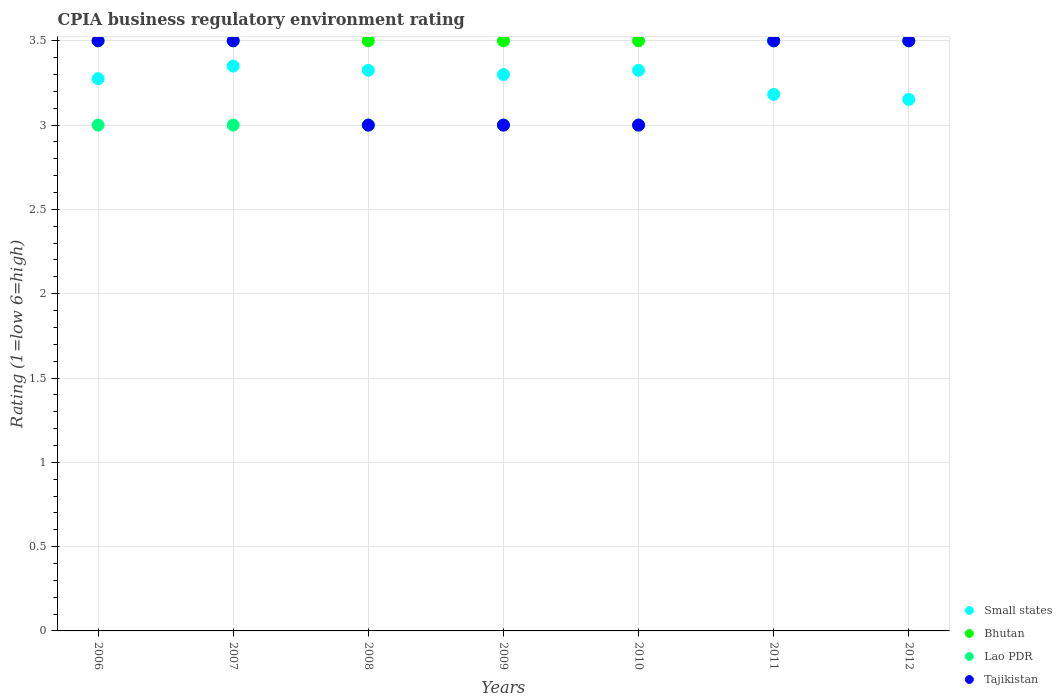Is the number of dotlines equal to the number of legend labels?
Provide a succinct answer. Yes. In which year was the CPIA rating in Small states maximum?
Your answer should be compact. 2007. What is the difference between the CPIA rating in Small states in 2011 and the CPIA rating in Tajikistan in 2007?
Keep it short and to the point. -0.32. What is the average CPIA rating in Tajikistan per year?
Your answer should be very brief. 3.29. In how many years, is the CPIA rating in Small states greater than 3?
Provide a succinct answer. 7. What is the difference between the highest and the lowest CPIA rating in Tajikistan?
Your response must be concise. 0.5. Is it the case that in every year, the sum of the CPIA rating in Small states and CPIA rating in Tajikistan  is greater than the sum of CPIA rating in Lao PDR and CPIA rating in Bhutan?
Offer a very short reply. No. Is it the case that in every year, the sum of the CPIA rating in Lao PDR and CPIA rating in Bhutan  is greater than the CPIA rating in Tajikistan?
Keep it short and to the point. Yes. Is the CPIA rating in Tajikistan strictly greater than the CPIA rating in Lao PDR over the years?
Offer a very short reply. No. Is the CPIA rating in Bhutan strictly less than the CPIA rating in Lao PDR over the years?
Give a very brief answer. No. How many years are there in the graph?
Make the answer very short. 7. Are the values on the major ticks of Y-axis written in scientific E-notation?
Your answer should be compact. No. Does the graph contain any zero values?
Your answer should be very brief. No. How many legend labels are there?
Your answer should be very brief. 4. What is the title of the graph?
Provide a succinct answer. CPIA business regulatory environment rating. Does "St. Lucia" appear as one of the legend labels in the graph?
Offer a terse response. No. What is the label or title of the Y-axis?
Offer a very short reply. Rating (1=low 6=high). What is the Rating (1=low 6=high) in Small states in 2006?
Keep it short and to the point. 3.27. What is the Rating (1=low 6=high) of Bhutan in 2006?
Your answer should be very brief. 3.5. What is the Rating (1=low 6=high) of Lao PDR in 2006?
Offer a terse response. 3. What is the Rating (1=low 6=high) of Small states in 2007?
Provide a succinct answer. 3.35. What is the Rating (1=low 6=high) in Lao PDR in 2007?
Your answer should be compact. 3. What is the Rating (1=low 6=high) in Tajikistan in 2007?
Make the answer very short. 3.5. What is the Rating (1=low 6=high) of Small states in 2008?
Offer a very short reply. 3.33. What is the Rating (1=low 6=high) in Bhutan in 2008?
Provide a short and direct response. 3.5. What is the Rating (1=low 6=high) in Lao PDR in 2008?
Ensure brevity in your answer.  3. What is the Rating (1=low 6=high) of Small states in 2009?
Keep it short and to the point. 3.3. What is the Rating (1=low 6=high) of Lao PDR in 2009?
Give a very brief answer. 3. What is the Rating (1=low 6=high) in Tajikistan in 2009?
Your answer should be very brief. 3. What is the Rating (1=low 6=high) in Small states in 2010?
Provide a succinct answer. 3.33. What is the Rating (1=low 6=high) of Small states in 2011?
Your response must be concise. 3.18. What is the Rating (1=low 6=high) in Tajikistan in 2011?
Provide a succinct answer. 3.5. What is the Rating (1=low 6=high) in Small states in 2012?
Make the answer very short. 3.15. What is the Rating (1=low 6=high) of Tajikistan in 2012?
Ensure brevity in your answer.  3.5. Across all years, what is the maximum Rating (1=low 6=high) of Small states?
Keep it short and to the point. 3.35. Across all years, what is the maximum Rating (1=low 6=high) of Bhutan?
Provide a short and direct response. 3.5. Across all years, what is the maximum Rating (1=low 6=high) of Lao PDR?
Provide a succinct answer. 3.5. Across all years, what is the maximum Rating (1=low 6=high) in Tajikistan?
Keep it short and to the point. 3.5. Across all years, what is the minimum Rating (1=low 6=high) in Small states?
Offer a very short reply. 3.15. Across all years, what is the minimum Rating (1=low 6=high) in Lao PDR?
Keep it short and to the point. 3. Across all years, what is the minimum Rating (1=low 6=high) in Tajikistan?
Your answer should be compact. 3. What is the total Rating (1=low 6=high) in Small states in the graph?
Provide a short and direct response. 22.91. What is the total Rating (1=low 6=high) of Bhutan in the graph?
Ensure brevity in your answer.  24.5. What is the difference between the Rating (1=low 6=high) of Small states in 2006 and that in 2007?
Provide a short and direct response. -0.07. What is the difference between the Rating (1=low 6=high) in Bhutan in 2006 and that in 2007?
Offer a very short reply. 0. What is the difference between the Rating (1=low 6=high) of Tajikistan in 2006 and that in 2007?
Ensure brevity in your answer.  0. What is the difference between the Rating (1=low 6=high) in Small states in 2006 and that in 2008?
Your answer should be very brief. -0.05. What is the difference between the Rating (1=low 6=high) of Bhutan in 2006 and that in 2008?
Give a very brief answer. 0. What is the difference between the Rating (1=low 6=high) in Lao PDR in 2006 and that in 2008?
Your response must be concise. 0. What is the difference between the Rating (1=low 6=high) in Small states in 2006 and that in 2009?
Your answer should be very brief. -0.03. What is the difference between the Rating (1=low 6=high) of Lao PDR in 2006 and that in 2009?
Provide a succinct answer. 0. What is the difference between the Rating (1=low 6=high) of Tajikistan in 2006 and that in 2009?
Keep it short and to the point. 0.5. What is the difference between the Rating (1=low 6=high) of Small states in 2006 and that in 2010?
Ensure brevity in your answer.  -0.05. What is the difference between the Rating (1=low 6=high) in Lao PDR in 2006 and that in 2010?
Keep it short and to the point. 0. What is the difference between the Rating (1=low 6=high) of Small states in 2006 and that in 2011?
Give a very brief answer. 0.09. What is the difference between the Rating (1=low 6=high) in Lao PDR in 2006 and that in 2011?
Provide a short and direct response. -0.5. What is the difference between the Rating (1=low 6=high) in Tajikistan in 2006 and that in 2011?
Offer a very short reply. 0. What is the difference between the Rating (1=low 6=high) of Small states in 2006 and that in 2012?
Provide a short and direct response. 0.12. What is the difference between the Rating (1=low 6=high) in Bhutan in 2006 and that in 2012?
Provide a succinct answer. 0. What is the difference between the Rating (1=low 6=high) of Tajikistan in 2006 and that in 2012?
Provide a succinct answer. 0. What is the difference between the Rating (1=low 6=high) of Small states in 2007 and that in 2008?
Your answer should be very brief. 0.03. What is the difference between the Rating (1=low 6=high) of Bhutan in 2007 and that in 2008?
Give a very brief answer. 0. What is the difference between the Rating (1=low 6=high) in Lao PDR in 2007 and that in 2008?
Your answer should be compact. 0. What is the difference between the Rating (1=low 6=high) in Tajikistan in 2007 and that in 2008?
Ensure brevity in your answer.  0.5. What is the difference between the Rating (1=low 6=high) of Small states in 2007 and that in 2009?
Your answer should be very brief. 0.05. What is the difference between the Rating (1=low 6=high) of Tajikistan in 2007 and that in 2009?
Make the answer very short. 0.5. What is the difference between the Rating (1=low 6=high) in Small states in 2007 and that in 2010?
Your answer should be compact. 0.03. What is the difference between the Rating (1=low 6=high) in Bhutan in 2007 and that in 2010?
Offer a terse response. 0. What is the difference between the Rating (1=low 6=high) of Small states in 2007 and that in 2011?
Offer a very short reply. 0.17. What is the difference between the Rating (1=low 6=high) in Lao PDR in 2007 and that in 2011?
Your answer should be very brief. -0.5. What is the difference between the Rating (1=low 6=high) in Small states in 2007 and that in 2012?
Ensure brevity in your answer.  0.2. What is the difference between the Rating (1=low 6=high) in Lao PDR in 2007 and that in 2012?
Keep it short and to the point. -0.5. What is the difference between the Rating (1=low 6=high) in Tajikistan in 2007 and that in 2012?
Your response must be concise. 0. What is the difference between the Rating (1=low 6=high) of Small states in 2008 and that in 2009?
Your response must be concise. 0.03. What is the difference between the Rating (1=low 6=high) in Lao PDR in 2008 and that in 2009?
Ensure brevity in your answer.  0. What is the difference between the Rating (1=low 6=high) in Tajikistan in 2008 and that in 2009?
Provide a short and direct response. 0. What is the difference between the Rating (1=low 6=high) in Bhutan in 2008 and that in 2010?
Your answer should be compact. 0. What is the difference between the Rating (1=low 6=high) in Tajikistan in 2008 and that in 2010?
Provide a short and direct response. 0. What is the difference between the Rating (1=low 6=high) in Small states in 2008 and that in 2011?
Your answer should be compact. 0.14. What is the difference between the Rating (1=low 6=high) of Tajikistan in 2008 and that in 2011?
Keep it short and to the point. -0.5. What is the difference between the Rating (1=low 6=high) of Small states in 2008 and that in 2012?
Give a very brief answer. 0.17. What is the difference between the Rating (1=low 6=high) in Bhutan in 2008 and that in 2012?
Provide a succinct answer. 0. What is the difference between the Rating (1=low 6=high) of Lao PDR in 2008 and that in 2012?
Make the answer very short. -0.5. What is the difference between the Rating (1=low 6=high) in Small states in 2009 and that in 2010?
Ensure brevity in your answer.  -0.03. What is the difference between the Rating (1=low 6=high) in Lao PDR in 2009 and that in 2010?
Give a very brief answer. 0. What is the difference between the Rating (1=low 6=high) in Tajikistan in 2009 and that in 2010?
Your answer should be compact. 0. What is the difference between the Rating (1=low 6=high) of Small states in 2009 and that in 2011?
Provide a short and direct response. 0.12. What is the difference between the Rating (1=low 6=high) in Small states in 2009 and that in 2012?
Your response must be concise. 0.15. What is the difference between the Rating (1=low 6=high) of Lao PDR in 2009 and that in 2012?
Your answer should be compact. -0.5. What is the difference between the Rating (1=low 6=high) in Tajikistan in 2009 and that in 2012?
Your answer should be compact. -0.5. What is the difference between the Rating (1=low 6=high) of Small states in 2010 and that in 2011?
Your answer should be compact. 0.14. What is the difference between the Rating (1=low 6=high) of Bhutan in 2010 and that in 2011?
Offer a terse response. 0. What is the difference between the Rating (1=low 6=high) in Tajikistan in 2010 and that in 2011?
Ensure brevity in your answer.  -0.5. What is the difference between the Rating (1=low 6=high) of Small states in 2010 and that in 2012?
Provide a succinct answer. 0.17. What is the difference between the Rating (1=low 6=high) in Bhutan in 2010 and that in 2012?
Provide a succinct answer. 0. What is the difference between the Rating (1=low 6=high) in Small states in 2011 and that in 2012?
Make the answer very short. 0.03. What is the difference between the Rating (1=low 6=high) of Bhutan in 2011 and that in 2012?
Provide a short and direct response. 0. What is the difference between the Rating (1=low 6=high) of Tajikistan in 2011 and that in 2012?
Your answer should be very brief. 0. What is the difference between the Rating (1=low 6=high) in Small states in 2006 and the Rating (1=low 6=high) in Bhutan in 2007?
Give a very brief answer. -0.23. What is the difference between the Rating (1=low 6=high) of Small states in 2006 and the Rating (1=low 6=high) of Lao PDR in 2007?
Keep it short and to the point. 0.28. What is the difference between the Rating (1=low 6=high) of Small states in 2006 and the Rating (1=low 6=high) of Tajikistan in 2007?
Give a very brief answer. -0.23. What is the difference between the Rating (1=low 6=high) in Bhutan in 2006 and the Rating (1=low 6=high) in Tajikistan in 2007?
Your answer should be very brief. 0. What is the difference between the Rating (1=low 6=high) in Lao PDR in 2006 and the Rating (1=low 6=high) in Tajikistan in 2007?
Provide a short and direct response. -0.5. What is the difference between the Rating (1=low 6=high) in Small states in 2006 and the Rating (1=low 6=high) in Bhutan in 2008?
Provide a short and direct response. -0.23. What is the difference between the Rating (1=low 6=high) of Small states in 2006 and the Rating (1=low 6=high) of Lao PDR in 2008?
Give a very brief answer. 0.28. What is the difference between the Rating (1=low 6=high) of Small states in 2006 and the Rating (1=low 6=high) of Tajikistan in 2008?
Keep it short and to the point. 0.28. What is the difference between the Rating (1=low 6=high) in Bhutan in 2006 and the Rating (1=low 6=high) in Lao PDR in 2008?
Provide a succinct answer. 0.5. What is the difference between the Rating (1=low 6=high) in Bhutan in 2006 and the Rating (1=low 6=high) in Tajikistan in 2008?
Provide a succinct answer. 0.5. What is the difference between the Rating (1=low 6=high) in Small states in 2006 and the Rating (1=low 6=high) in Bhutan in 2009?
Your answer should be compact. -0.23. What is the difference between the Rating (1=low 6=high) of Small states in 2006 and the Rating (1=low 6=high) of Lao PDR in 2009?
Offer a terse response. 0.28. What is the difference between the Rating (1=low 6=high) of Small states in 2006 and the Rating (1=low 6=high) of Tajikistan in 2009?
Provide a succinct answer. 0.28. What is the difference between the Rating (1=low 6=high) in Bhutan in 2006 and the Rating (1=low 6=high) in Lao PDR in 2009?
Provide a short and direct response. 0.5. What is the difference between the Rating (1=low 6=high) in Lao PDR in 2006 and the Rating (1=low 6=high) in Tajikistan in 2009?
Offer a very short reply. 0. What is the difference between the Rating (1=low 6=high) of Small states in 2006 and the Rating (1=low 6=high) of Bhutan in 2010?
Give a very brief answer. -0.23. What is the difference between the Rating (1=low 6=high) of Small states in 2006 and the Rating (1=low 6=high) of Lao PDR in 2010?
Provide a succinct answer. 0.28. What is the difference between the Rating (1=low 6=high) of Small states in 2006 and the Rating (1=low 6=high) of Tajikistan in 2010?
Your response must be concise. 0.28. What is the difference between the Rating (1=low 6=high) of Bhutan in 2006 and the Rating (1=low 6=high) of Tajikistan in 2010?
Provide a short and direct response. 0.5. What is the difference between the Rating (1=low 6=high) of Small states in 2006 and the Rating (1=low 6=high) of Bhutan in 2011?
Give a very brief answer. -0.23. What is the difference between the Rating (1=low 6=high) of Small states in 2006 and the Rating (1=low 6=high) of Lao PDR in 2011?
Provide a succinct answer. -0.23. What is the difference between the Rating (1=low 6=high) in Small states in 2006 and the Rating (1=low 6=high) in Tajikistan in 2011?
Make the answer very short. -0.23. What is the difference between the Rating (1=low 6=high) of Bhutan in 2006 and the Rating (1=low 6=high) of Lao PDR in 2011?
Provide a short and direct response. 0. What is the difference between the Rating (1=low 6=high) of Bhutan in 2006 and the Rating (1=low 6=high) of Tajikistan in 2011?
Offer a very short reply. 0. What is the difference between the Rating (1=low 6=high) in Small states in 2006 and the Rating (1=low 6=high) in Bhutan in 2012?
Ensure brevity in your answer.  -0.23. What is the difference between the Rating (1=low 6=high) in Small states in 2006 and the Rating (1=low 6=high) in Lao PDR in 2012?
Provide a short and direct response. -0.23. What is the difference between the Rating (1=low 6=high) of Small states in 2006 and the Rating (1=low 6=high) of Tajikistan in 2012?
Offer a very short reply. -0.23. What is the difference between the Rating (1=low 6=high) in Bhutan in 2006 and the Rating (1=low 6=high) in Lao PDR in 2012?
Ensure brevity in your answer.  0. What is the difference between the Rating (1=low 6=high) of Lao PDR in 2007 and the Rating (1=low 6=high) of Tajikistan in 2008?
Make the answer very short. 0. What is the difference between the Rating (1=low 6=high) in Small states in 2007 and the Rating (1=low 6=high) in Bhutan in 2009?
Offer a terse response. -0.15. What is the difference between the Rating (1=low 6=high) in Small states in 2007 and the Rating (1=low 6=high) in Tajikistan in 2010?
Your response must be concise. 0.35. What is the difference between the Rating (1=low 6=high) in Bhutan in 2007 and the Rating (1=low 6=high) in Tajikistan in 2010?
Your answer should be very brief. 0.5. What is the difference between the Rating (1=low 6=high) in Lao PDR in 2007 and the Rating (1=low 6=high) in Tajikistan in 2010?
Keep it short and to the point. 0. What is the difference between the Rating (1=low 6=high) in Bhutan in 2007 and the Rating (1=low 6=high) in Lao PDR in 2011?
Ensure brevity in your answer.  0. What is the difference between the Rating (1=low 6=high) of Bhutan in 2007 and the Rating (1=low 6=high) of Tajikistan in 2011?
Provide a succinct answer. 0. What is the difference between the Rating (1=low 6=high) in Lao PDR in 2007 and the Rating (1=low 6=high) in Tajikistan in 2011?
Keep it short and to the point. -0.5. What is the difference between the Rating (1=low 6=high) in Small states in 2007 and the Rating (1=low 6=high) in Tajikistan in 2012?
Give a very brief answer. -0.15. What is the difference between the Rating (1=low 6=high) of Bhutan in 2007 and the Rating (1=low 6=high) of Lao PDR in 2012?
Your answer should be very brief. 0. What is the difference between the Rating (1=low 6=high) of Bhutan in 2007 and the Rating (1=low 6=high) of Tajikistan in 2012?
Your response must be concise. 0. What is the difference between the Rating (1=low 6=high) in Lao PDR in 2007 and the Rating (1=low 6=high) in Tajikistan in 2012?
Make the answer very short. -0.5. What is the difference between the Rating (1=low 6=high) of Small states in 2008 and the Rating (1=low 6=high) of Bhutan in 2009?
Offer a terse response. -0.17. What is the difference between the Rating (1=low 6=high) of Small states in 2008 and the Rating (1=low 6=high) of Lao PDR in 2009?
Ensure brevity in your answer.  0.33. What is the difference between the Rating (1=low 6=high) of Small states in 2008 and the Rating (1=low 6=high) of Tajikistan in 2009?
Offer a terse response. 0.33. What is the difference between the Rating (1=low 6=high) in Small states in 2008 and the Rating (1=low 6=high) in Bhutan in 2010?
Your response must be concise. -0.17. What is the difference between the Rating (1=low 6=high) of Small states in 2008 and the Rating (1=low 6=high) of Lao PDR in 2010?
Keep it short and to the point. 0.33. What is the difference between the Rating (1=low 6=high) of Small states in 2008 and the Rating (1=low 6=high) of Tajikistan in 2010?
Your answer should be very brief. 0.33. What is the difference between the Rating (1=low 6=high) in Bhutan in 2008 and the Rating (1=low 6=high) in Tajikistan in 2010?
Provide a succinct answer. 0.5. What is the difference between the Rating (1=low 6=high) in Small states in 2008 and the Rating (1=low 6=high) in Bhutan in 2011?
Provide a succinct answer. -0.17. What is the difference between the Rating (1=low 6=high) in Small states in 2008 and the Rating (1=low 6=high) in Lao PDR in 2011?
Offer a terse response. -0.17. What is the difference between the Rating (1=low 6=high) in Small states in 2008 and the Rating (1=low 6=high) in Tajikistan in 2011?
Offer a terse response. -0.17. What is the difference between the Rating (1=low 6=high) of Bhutan in 2008 and the Rating (1=low 6=high) of Lao PDR in 2011?
Ensure brevity in your answer.  0. What is the difference between the Rating (1=low 6=high) of Bhutan in 2008 and the Rating (1=low 6=high) of Tajikistan in 2011?
Keep it short and to the point. 0. What is the difference between the Rating (1=low 6=high) in Small states in 2008 and the Rating (1=low 6=high) in Bhutan in 2012?
Keep it short and to the point. -0.17. What is the difference between the Rating (1=low 6=high) in Small states in 2008 and the Rating (1=low 6=high) in Lao PDR in 2012?
Offer a terse response. -0.17. What is the difference between the Rating (1=low 6=high) in Small states in 2008 and the Rating (1=low 6=high) in Tajikistan in 2012?
Make the answer very short. -0.17. What is the difference between the Rating (1=low 6=high) in Bhutan in 2008 and the Rating (1=low 6=high) in Lao PDR in 2012?
Your answer should be very brief. 0. What is the difference between the Rating (1=low 6=high) in Bhutan in 2008 and the Rating (1=low 6=high) in Tajikistan in 2012?
Ensure brevity in your answer.  0. What is the difference between the Rating (1=low 6=high) of Lao PDR in 2008 and the Rating (1=low 6=high) of Tajikistan in 2012?
Provide a succinct answer. -0.5. What is the difference between the Rating (1=low 6=high) in Small states in 2009 and the Rating (1=low 6=high) in Bhutan in 2010?
Keep it short and to the point. -0.2. What is the difference between the Rating (1=low 6=high) in Small states in 2009 and the Rating (1=low 6=high) in Tajikistan in 2010?
Make the answer very short. 0.3. What is the difference between the Rating (1=low 6=high) in Lao PDR in 2009 and the Rating (1=low 6=high) in Tajikistan in 2011?
Your answer should be compact. -0.5. What is the difference between the Rating (1=low 6=high) in Small states in 2009 and the Rating (1=low 6=high) in Bhutan in 2012?
Offer a very short reply. -0.2. What is the difference between the Rating (1=low 6=high) of Bhutan in 2009 and the Rating (1=low 6=high) of Lao PDR in 2012?
Your answer should be compact. 0. What is the difference between the Rating (1=low 6=high) of Small states in 2010 and the Rating (1=low 6=high) of Bhutan in 2011?
Your answer should be very brief. -0.17. What is the difference between the Rating (1=low 6=high) of Small states in 2010 and the Rating (1=low 6=high) of Lao PDR in 2011?
Ensure brevity in your answer.  -0.17. What is the difference between the Rating (1=low 6=high) in Small states in 2010 and the Rating (1=low 6=high) in Tajikistan in 2011?
Your response must be concise. -0.17. What is the difference between the Rating (1=low 6=high) of Bhutan in 2010 and the Rating (1=low 6=high) of Lao PDR in 2011?
Your answer should be very brief. 0. What is the difference between the Rating (1=low 6=high) of Bhutan in 2010 and the Rating (1=low 6=high) of Tajikistan in 2011?
Your answer should be compact. 0. What is the difference between the Rating (1=low 6=high) of Lao PDR in 2010 and the Rating (1=low 6=high) of Tajikistan in 2011?
Offer a very short reply. -0.5. What is the difference between the Rating (1=low 6=high) in Small states in 2010 and the Rating (1=low 6=high) in Bhutan in 2012?
Your answer should be very brief. -0.17. What is the difference between the Rating (1=low 6=high) of Small states in 2010 and the Rating (1=low 6=high) of Lao PDR in 2012?
Offer a very short reply. -0.17. What is the difference between the Rating (1=low 6=high) of Small states in 2010 and the Rating (1=low 6=high) of Tajikistan in 2012?
Keep it short and to the point. -0.17. What is the difference between the Rating (1=low 6=high) of Bhutan in 2010 and the Rating (1=low 6=high) of Tajikistan in 2012?
Keep it short and to the point. 0. What is the difference between the Rating (1=low 6=high) of Small states in 2011 and the Rating (1=low 6=high) of Bhutan in 2012?
Keep it short and to the point. -0.32. What is the difference between the Rating (1=low 6=high) of Small states in 2011 and the Rating (1=low 6=high) of Lao PDR in 2012?
Make the answer very short. -0.32. What is the difference between the Rating (1=low 6=high) of Small states in 2011 and the Rating (1=low 6=high) of Tajikistan in 2012?
Your response must be concise. -0.32. What is the difference between the Rating (1=low 6=high) of Lao PDR in 2011 and the Rating (1=low 6=high) of Tajikistan in 2012?
Provide a short and direct response. 0. What is the average Rating (1=low 6=high) of Small states per year?
Give a very brief answer. 3.27. What is the average Rating (1=low 6=high) in Lao PDR per year?
Make the answer very short. 3.14. What is the average Rating (1=low 6=high) in Tajikistan per year?
Provide a short and direct response. 3.29. In the year 2006, what is the difference between the Rating (1=low 6=high) in Small states and Rating (1=low 6=high) in Bhutan?
Provide a succinct answer. -0.23. In the year 2006, what is the difference between the Rating (1=low 6=high) of Small states and Rating (1=low 6=high) of Lao PDR?
Ensure brevity in your answer.  0.28. In the year 2006, what is the difference between the Rating (1=low 6=high) of Small states and Rating (1=low 6=high) of Tajikistan?
Ensure brevity in your answer.  -0.23. In the year 2006, what is the difference between the Rating (1=low 6=high) of Bhutan and Rating (1=low 6=high) of Lao PDR?
Ensure brevity in your answer.  0.5. In the year 2006, what is the difference between the Rating (1=low 6=high) in Bhutan and Rating (1=low 6=high) in Tajikistan?
Give a very brief answer. 0. In the year 2007, what is the difference between the Rating (1=low 6=high) in Small states and Rating (1=low 6=high) in Lao PDR?
Make the answer very short. 0.35. In the year 2007, what is the difference between the Rating (1=low 6=high) of Small states and Rating (1=low 6=high) of Tajikistan?
Ensure brevity in your answer.  -0.15. In the year 2007, what is the difference between the Rating (1=low 6=high) of Bhutan and Rating (1=low 6=high) of Lao PDR?
Keep it short and to the point. 0.5. In the year 2007, what is the difference between the Rating (1=low 6=high) of Bhutan and Rating (1=low 6=high) of Tajikistan?
Make the answer very short. 0. In the year 2007, what is the difference between the Rating (1=low 6=high) in Lao PDR and Rating (1=low 6=high) in Tajikistan?
Your response must be concise. -0.5. In the year 2008, what is the difference between the Rating (1=low 6=high) of Small states and Rating (1=low 6=high) of Bhutan?
Ensure brevity in your answer.  -0.17. In the year 2008, what is the difference between the Rating (1=low 6=high) in Small states and Rating (1=low 6=high) in Lao PDR?
Provide a succinct answer. 0.33. In the year 2008, what is the difference between the Rating (1=low 6=high) in Small states and Rating (1=low 6=high) in Tajikistan?
Your response must be concise. 0.33. In the year 2008, what is the difference between the Rating (1=low 6=high) of Bhutan and Rating (1=low 6=high) of Tajikistan?
Make the answer very short. 0.5. In the year 2009, what is the difference between the Rating (1=low 6=high) in Small states and Rating (1=low 6=high) in Tajikistan?
Your answer should be compact. 0.3. In the year 2009, what is the difference between the Rating (1=low 6=high) in Bhutan and Rating (1=low 6=high) in Lao PDR?
Provide a succinct answer. 0.5. In the year 2009, what is the difference between the Rating (1=low 6=high) of Bhutan and Rating (1=low 6=high) of Tajikistan?
Make the answer very short. 0.5. In the year 2009, what is the difference between the Rating (1=low 6=high) of Lao PDR and Rating (1=low 6=high) of Tajikistan?
Provide a succinct answer. 0. In the year 2010, what is the difference between the Rating (1=low 6=high) of Small states and Rating (1=low 6=high) of Bhutan?
Offer a very short reply. -0.17. In the year 2010, what is the difference between the Rating (1=low 6=high) of Small states and Rating (1=low 6=high) of Lao PDR?
Provide a short and direct response. 0.33. In the year 2010, what is the difference between the Rating (1=low 6=high) of Small states and Rating (1=low 6=high) of Tajikistan?
Give a very brief answer. 0.33. In the year 2010, what is the difference between the Rating (1=low 6=high) of Bhutan and Rating (1=low 6=high) of Lao PDR?
Give a very brief answer. 0.5. In the year 2010, what is the difference between the Rating (1=low 6=high) of Lao PDR and Rating (1=low 6=high) of Tajikistan?
Offer a very short reply. 0. In the year 2011, what is the difference between the Rating (1=low 6=high) in Small states and Rating (1=low 6=high) in Bhutan?
Keep it short and to the point. -0.32. In the year 2011, what is the difference between the Rating (1=low 6=high) of Small states and Rating (1=low 6=high) of Lao PDR?
Your response must be concise. -0.32. In the year 2011, what is the difference between the Rating (1=low 6=high) of Small states and Rating (1=low 6=high) of Tajikistan?
Your answer should be very brief. -0.32. In the year 2011, what is the difference between the Rating (1=low 6=high) in Bhutan and Rating (1=low 6=high) in Lao PDR?
Give a very brief answer. 0. In the year 2012, what is the difference between the Rating (1=low 6=high) of Small states and Rating (1=low 6=high) of Bhutan?
Provide a short and direct response. -0.35. In the year 2012, what is the difference between the Rating (1=low 6=high) of Small states and Rating (1=low 6=high) of Lao PDR?
Your answer should be compact. -0.35. In the year 2012, what is the difference between the Rating (1=low 6=high) in Small states and Rating (1=low 6=high) in Tajikistan?
Make the answer very short. -0.35. In the year 2012, what is the difference between the Rating (1=low 6=high) of Bhutan and Rating (1=low 6=high) of Tajikistan?
Ensure brevity in your answer.  0. What is the ratio of the Rating (1=low 6=high) of Small states in 2006 to that in 2007?
Offer a terse response. 0.98. What is the ratio of the Rating (1=low 6=high) of Lao PDR in 2006 to that in 2007?
Provide a short and direct response. 1. What is the ratio of the Rating (1=low 6=high) in Small states in 2006 to that in 2009?
Provide a short and direct response. 0.99. What is the ratio of the Rating (1=low 6=high) in Bhutan in 2006 to that in 2009?
Offer a very short reply. 1. What is the ratio of the Rating (1=low 6=high) in Lao PDR in 2006 to that in 2009?
Ensure brevity in your answer.  1. What is the ratio of the Rating (1=low 6=high) of Bhutan in 2006 to that in 2010?
Your response must be concise. 1. What is the ratio of the Rating (1=low 6=high) of Lao PDR in 2006 to that in 2010?
Give a very brief answer. 1. What is the ratio of the Rating (1=low 6=high) in Small states in 2006 to that in 2011?
Provide a short and direct response. 1.03. What is the ratio of the Rating (1=low 6=high) in Bhutan in 2006 to that in 2011?
Make the answer very short. 1. What is the ratio of the Rating (1=low 6=high) in Small states in 2006 to that in 2012?
Give a very brief answer. 1.04. What is the ratio of the Rating (1=low 6=high) of Bhutan in 2006 to that in 2012?
Your answer should be very brief. 1. What is the ratio of the Rating (1=low 6=high) in Tajikistan in 2006 to that in 2012?
Your response must be concise. 1. What is the ratio of the Rating (1=low 6=high) in Small states in 2007 to that in 2008?
Offer a very short reply. 1.01. What is the ratio of the Rating (1=low 6=high) of Lao PDR in 2007 to that in 2008?
Offer a very short reply. 1. What is the ratio of the Rating (1=low 6=high) in Tajikistan in 2007 to that in 2008?
Offer a very short reply. 1.17. What is the ratio of the Rating (1=low 6=high) of Small states in 2007 to that in 2009?
Provide a succinct answer. 1.02. What is the ratio of the Rating (1=low 6=high) in Bhutan in 2007 to that in 2009?
Provide a short and direct response. 1. What is the ratio of the Rating (1=low 6=high) in Small states in 2007 to that in 2010?
Give a very brief answer. 1.01. What is the ratio of the Rating (1=low 6=high) of Tajikistan in 2007 to that in 2010?
Offer a very short reply. 1.17. What is the ratio of the Rating (1=low 6=high) of Small states in 2007 to that in 2011?
Ensure brevity in your answer.  1.05. What is the ratio of the Rating (1=low 6=high) in Bhutan in 2007 to that in 2011?
Your response must be concise. 1. What is the ratio of the Rating (1=low 6=high) of Small states in 2007 to that in 2012?
Provide a short and direct response. 1.06. What is the ratio of the Rating (1=low 6=high) of Bhutan in 2007 to that in 2012?
Provide a short and direct response. 1. What is the ratio of the Rating (1=low 6=high) in Small states in 2008 to that in 2009?
Offer a very short reply. 1.01. What is the ratio of the Rating (1=low 6=high) of Bhutan in 2008 to that in 2009?
Give a very brief answer. 1. What is the ratio of the Rating (1=low 6=high) of Tajikistan in 2008 to that in 2009?
Offer a very short reply. 1. What is the ratio of the Rating (1=low 6=high) of Small states in 2008 to that in 2010?
Give a very brief answer. 1. What is the ratio of the Rating (1=low 6=high) in Bhutan in 2008 to that in 2010?
Your answer should be very brief. 1. What is the ratio of the Rating (1=low 6=high) of Lao PDR in 2008 to that in 2010?
Ensure brevity in your answer.  1. What is the ratio of the Rating (1=low 6=high) of Tajikistan in 2008 to that in 2010?
Give a very brief answer. 1. What is the ratio of the Rating (1=low 6=high) in Small states in 2008 to that in 2011?
Provide a short and direct response. 1.04. What is the ratio of the Rating (1=low 6=high) of Small states in 2008 to that in 2012?
Provide a short and direct response. 1.05. What is the ratio of the Rating (1=low 6=high) of Tajikistan in 2008 to that in 2012?
Your response must be concise. 0.86. What is the ratio of the Rating (1=low 6=high) in Small states in 2009 to that in 2011?
Give a very brief answer. 1.04. What is the ratio of the Rating (1=low 6=high) of Tajikistan in 2009 to that in 2011?
Your answer should be compact. 0.86. What is the ratio of the Rating (1=low 6=high) of Small states in 2009 to that in 2012?
Offer a terse response. 1.05. What is the ratio of the Rating (1=low 6=high) in Bhutan in 2009 to that in 2012?
Your answer should be compact. 1. What is the ratio of the Rating (1=low 6=high) in Lao PDR in 2009 to that in 2012?
Ensure brevity in your answer.  0.86. What is the ratio of the Rating (1=low 6=high) of Small states in 2010 to that in 2011?
Ensure brevity in your answer.  1.04. What is the ratio of the Rating (1=low 6=high) of Lao PDR in 2010 to that in 2011?
Your answer should be compact. 0.86. What is the ratio of the Rating (1=low 6=high) of Small states in 2010 to that in 2012?
Your answer should be very brief. 1.05. What is the ratio of the Rating (1=low 6=high) of Bhutan in 2010 to that in 2012?
Give a very brief answer. 1. What is the ratio of the Rating (1=low 6=high) in Small states in 2011 to that in 2012?
Your answer should be very brief. 1.01. What is the difference between the highest and the second highest Rating (1=low 6=high) in Small states?
Offer a very short reply. 0.03. What is the difference between the highest and the second highest Rating (1=low 6=high) in Bhutan?
Your answer should be very brief. 0. What is the difference between the highest and the second highest Rating (1=low 6=high) in Lao PDR?
Make the answer very short. 0. What is the difference between the highest and the lowest Rating (1=low 6=high) in Small states?
Your answer should be very brief. 0.2. What is the difference between the highest and the lowest Rating (1=low 6=high) of Bhutan?
Ensure brevity in your answer.  0. What is the difference between the highest and the lowest Rating (1=low 6=high) of Lao PDR?
Your answer should be very brief. 0.5. What is the difference between the highest and the lowest Rating (1=low 6=high) in Tajikistan?
Ensure brevity in your answer.  0.5. 